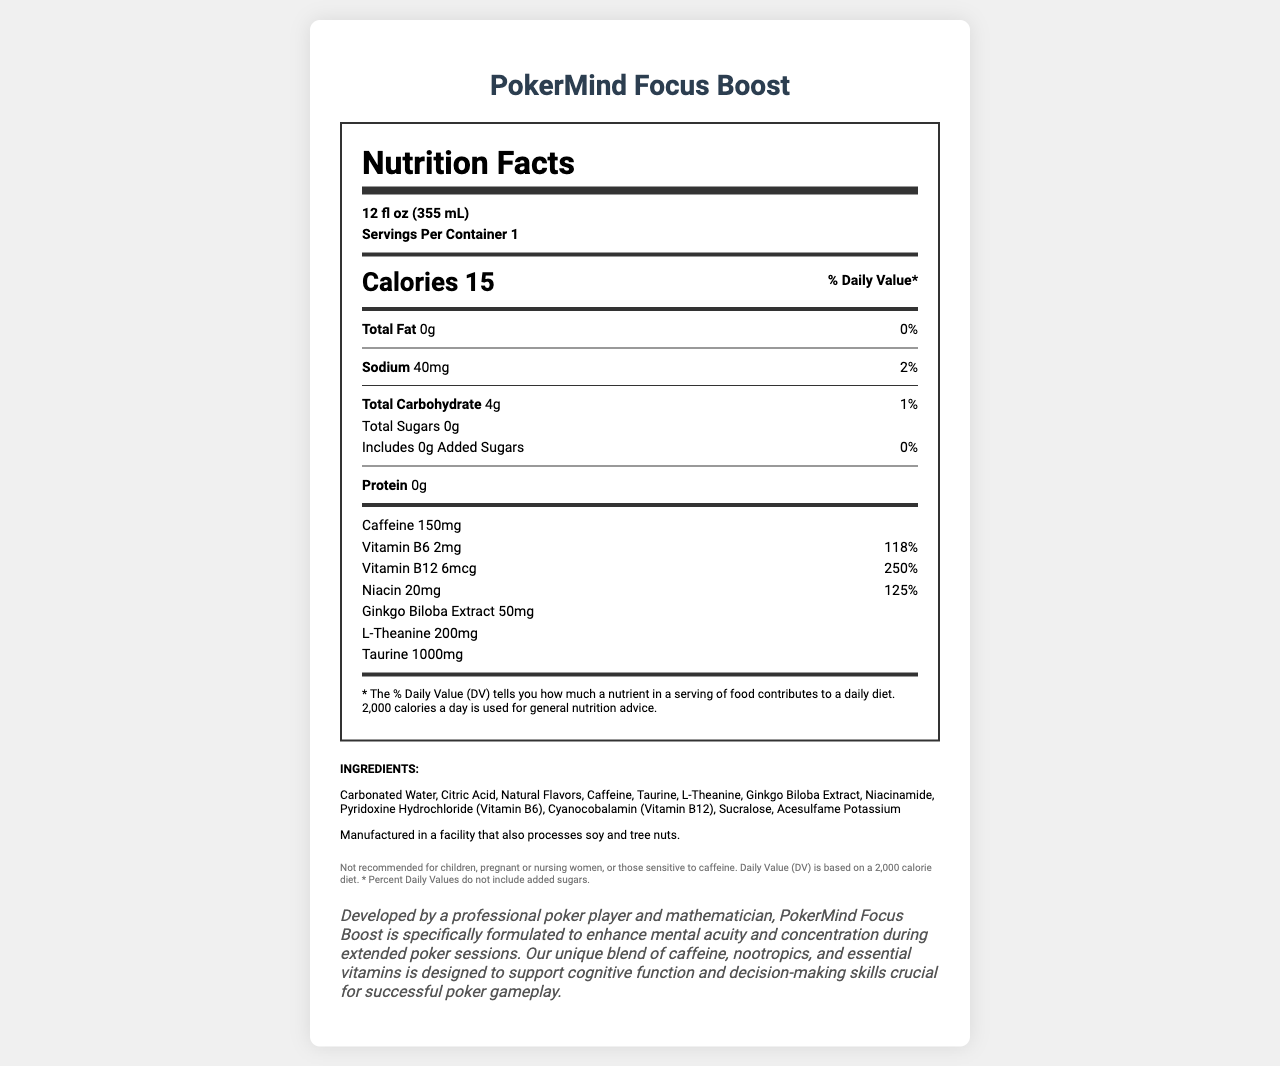What is the serving size for PokerMind Focus Boost? The serving size is explicitly mentioned at the top of the Nutrition Facts section.
Answer: 12 fl oz (355 mL) How many calories are in one serving of PokerMind Focus Boost? The calories per serving are shown in a bold, large font within the Nutrition Facts section.
Answer: 15 calories What percentage of the daily value of Vitamin B12 is provided in one serving? The daily value percentage for Vitamin B12 is listed next to the amount, indicating 250%.
Answer: 250% How much caffeine is contained in one serving? The amount of caffeine per serving is clearly stated in the Nutrition Facts section.
Answer: 150mg What are the total carbohydrates present in one serving? The total carbohydrate content is listed alongside a daily value percentage of 1%.
Answer: 4g How much sodium does one serving contain? The sodium content per serving is listed with a daily value of 2%.
Answer: 40mg Which of the following ingredients is not listed in PokerMind Focus Boost? A. Caffeine B. Taurine C. Sugar D. Citric Acid The ingredient list does not include sugar; in fact, the document states 0 grams of total and added sugars.
Answer: C. Sugar What percentage of the daily value of niacin is in PokerMind Focus Boost? A. 118% B. 125% C. 250% D. 2% The daily value percentage for niacin is clearly labeled as 125%.
Answer: B. 125% Is PokerMind Focus Boost recommended for children? A disclaimer at the bottom of the document states it is not recommended for children.
Answer: No Summarize the primary purpose and ingredients of PokerMind Focus Boost. The document details both the nutritional content and the ingredient list, and includes a brand story that explains the product's purpose and development.
Answer: PokerMind Focus Boost is designed to enhance mental acuity and concentration during long poker sessions. It contains caffeine, nootropics, essential vitamins (like Vitamin B6, B12, and niacin), and other ingredients like taurine, L-theanine, and Ginkgo Biloba Extract while having 15 calories per serving. How many servings are in one container? The number of servings per container is clearly mentioned next to the serving size.
Answer: 1 What is the primary purpose of the product according to its brand story? The brand story explains the reason behind the product's formulation, specifically for poker players to support cognitive function and decision-making skills.
Answer: To enhance mental acuity and concentration during extended poker sessions. Does PokerMind Focus Boost contain any protein? The document states 0 grams of protein per serving.
Answer: No What is the amount of total sugars in one serving of PokerMind Focus Boost? The total sugar content is explicitly mentioned as 0 grams.
Answer: 0g What is the facility allergen information mentioned in the document? The allergen information is listed at the bottom of the document.
Answer: Manufactured in a facility that also processes soy and tree nuts. How does the document describe the taste of PokerMind Focus Boost? The document does not provide any information about the taste of the beverage.
Answer: Unknown 